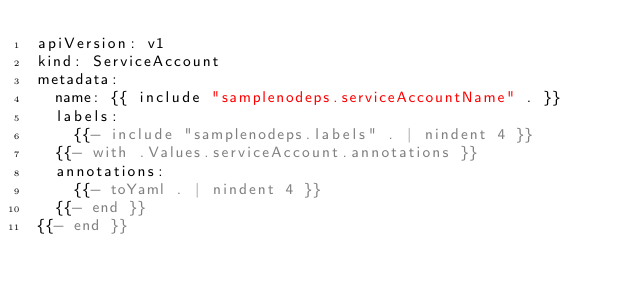Convert code to text. <code><loc_0><loc_0><loc_500><loc_500><_YAML_>apiVersion: v1
kind: ServiceAccount
metadata:
  name: {{ include "samplenodeps.serviceAccountName" . }}
  labels:
    {{- include "samplenodeps.labels" . | nindent 4 }}
  {{- with .Values.serviceAccount.annotations }}
  annotations:
    {{- toYaml . | nindent 4 }}
  {{- end }}
{{- end }}
</code> 